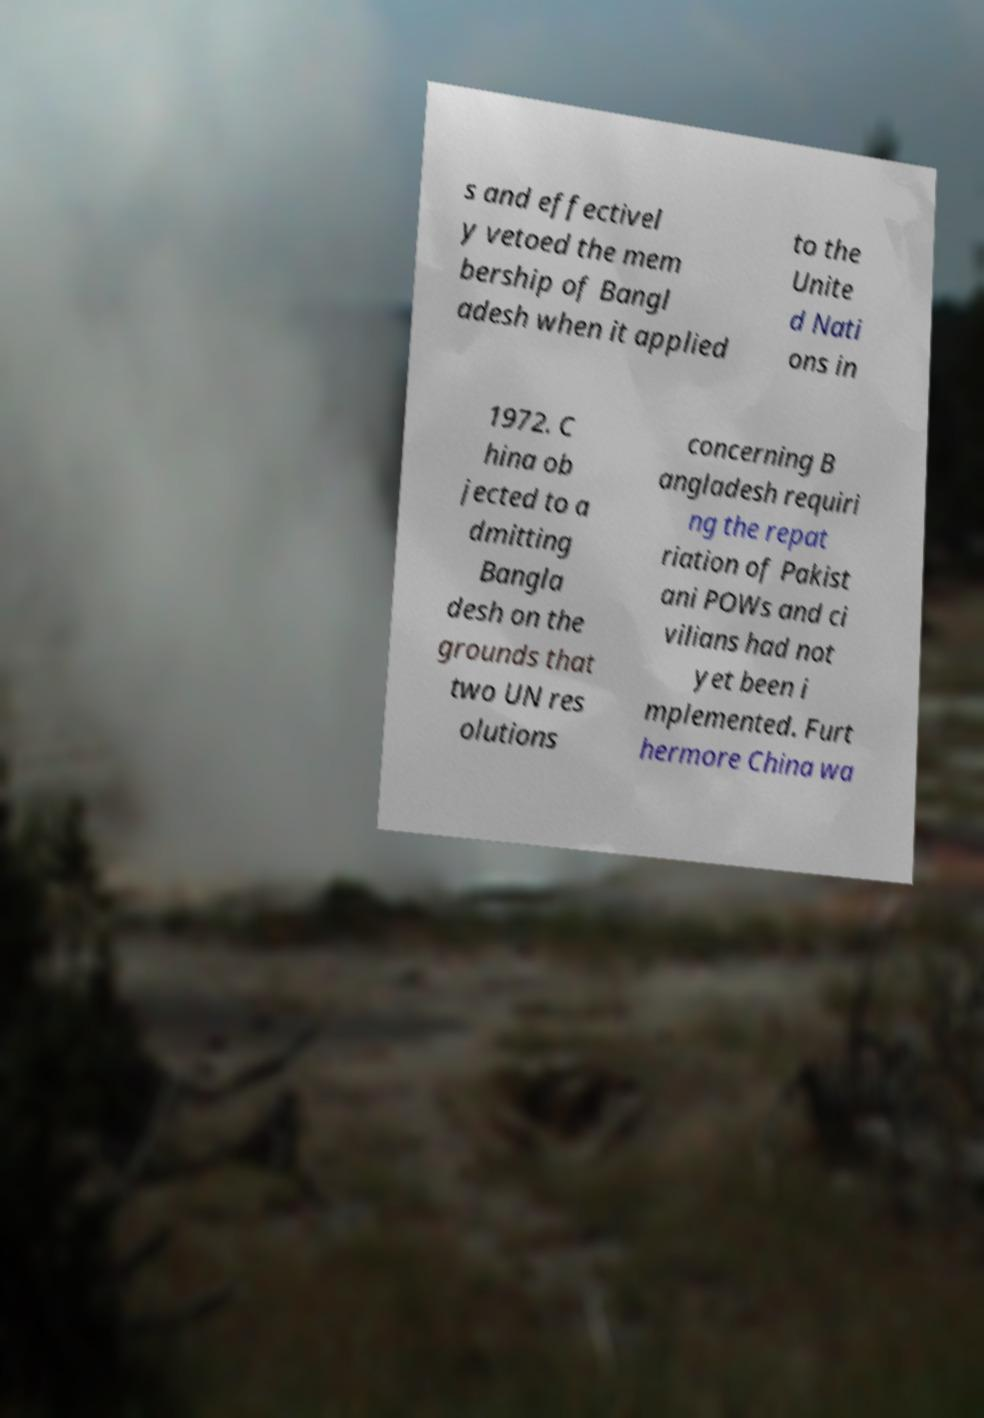Can you read and provide the text displayed in the image?This photo seems to have some interesting text. Can you extract and type it out for me? s and effectivel y vetoed the mem bership of Bangl adesh when it applied to the Unite d Nati ons in 1972. C hina ob jected to a dmitting Bangla desh on the grounds that two UN res olutions concerning B angladesh requiri ng the repat riation of Pakist ani POWs and ci vilians had not yet been i mplemented. Furt hermore China wa 